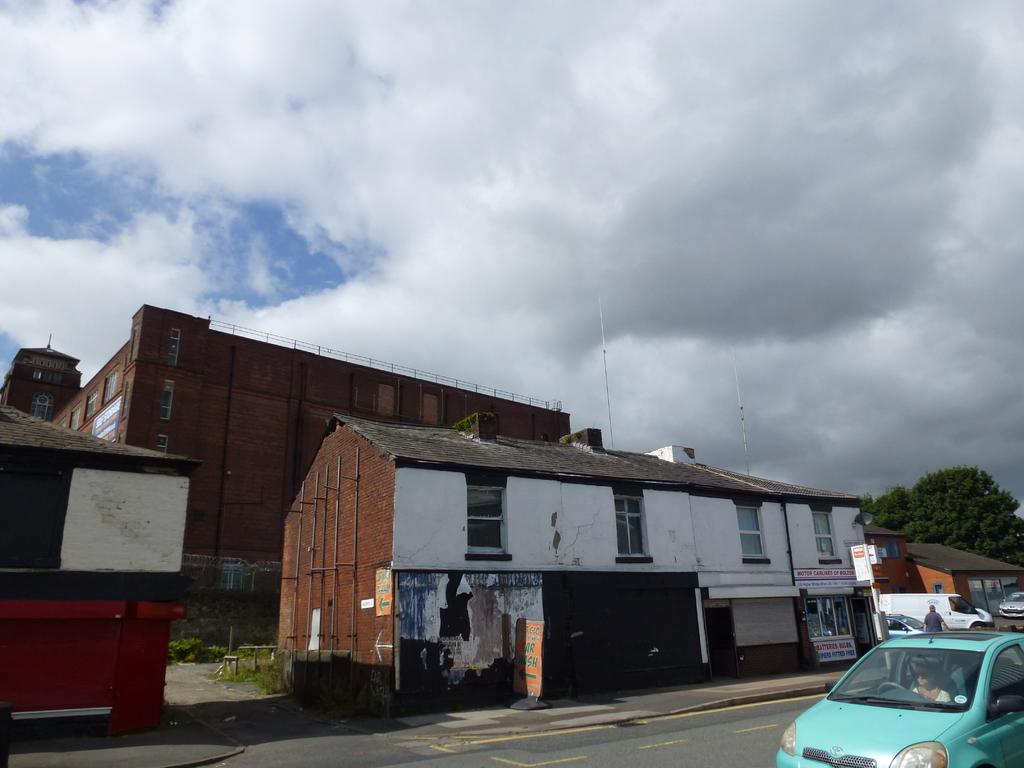What type of structures can be seen in the image? There are buildings in the image. What is happening on the right side of the image? There are vehicles on the road on the right side of the image. Can you identify any living beings in the image? Yes, there is a person visible in the image. What can be seen in the background of the image? The sky is visible in the background of the image. What type of tin is being used to construct the buildings in the image? There is no mention of tin being used to construct the buildings in the image. The buildings are likely made of more conventional materials like concrete, brick, or steel. 